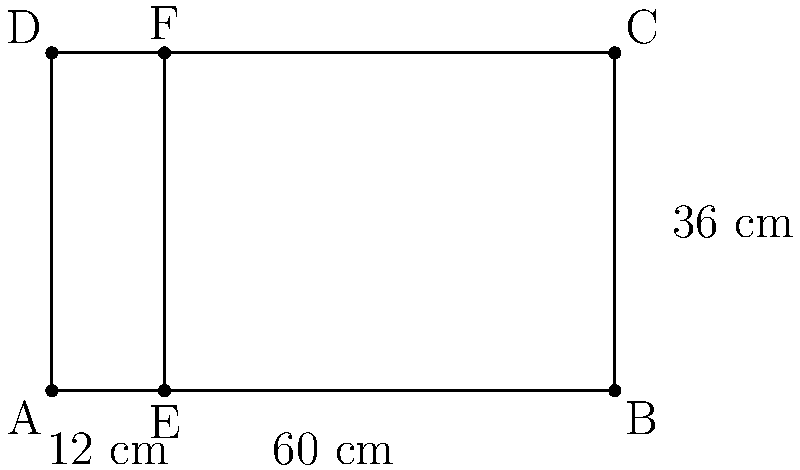You're designing a new record shelf for your store. The shelf is represented by the rectangle ABCD in the diagram. If each vinyl record takes up 12 cm of shelf width (represented by EF), how many records can this shelf hold? Assume records are stored vertically and take up the full height of the shelf. To solve this problem, we need to follow these steps:

1. Identify the width of the shelf:
   The width of the shelf is represented by AB in the diagram.
   We're given that AB = 60 cm.

2. Identify the width needed for each record:
   Each record takes up 12 cm of shelf width, represented by EF.

3. Calculate the number of records that can fit:
   We can use the formula:
   $$\text{Number of records} = \frac{\text{Shelf width}}{\text{Width per record}}$$

   Plugging in the values:
   $$\text{Number of records} = \frac{60 \text{ cm}}{12 \text{ cm}}$$

4. Perform the division:
   $$\text{Number of records} = 5$$

Therefore, this shelf can hold 5 records.
Answer: 5 records 